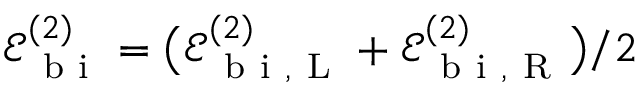Convert formula to latex. <formula><loc_0><loc_0><loc_500><loc_500>\mathcal { E } _ { b i } ^ { ( 2 ) } = \left ( \mathcal { E } _ { b i , L } ^ { ( 2 ) } + \mathcal { E } _ { b i , R } ^ { ( 2 ) } \right ) / 2</formula> 